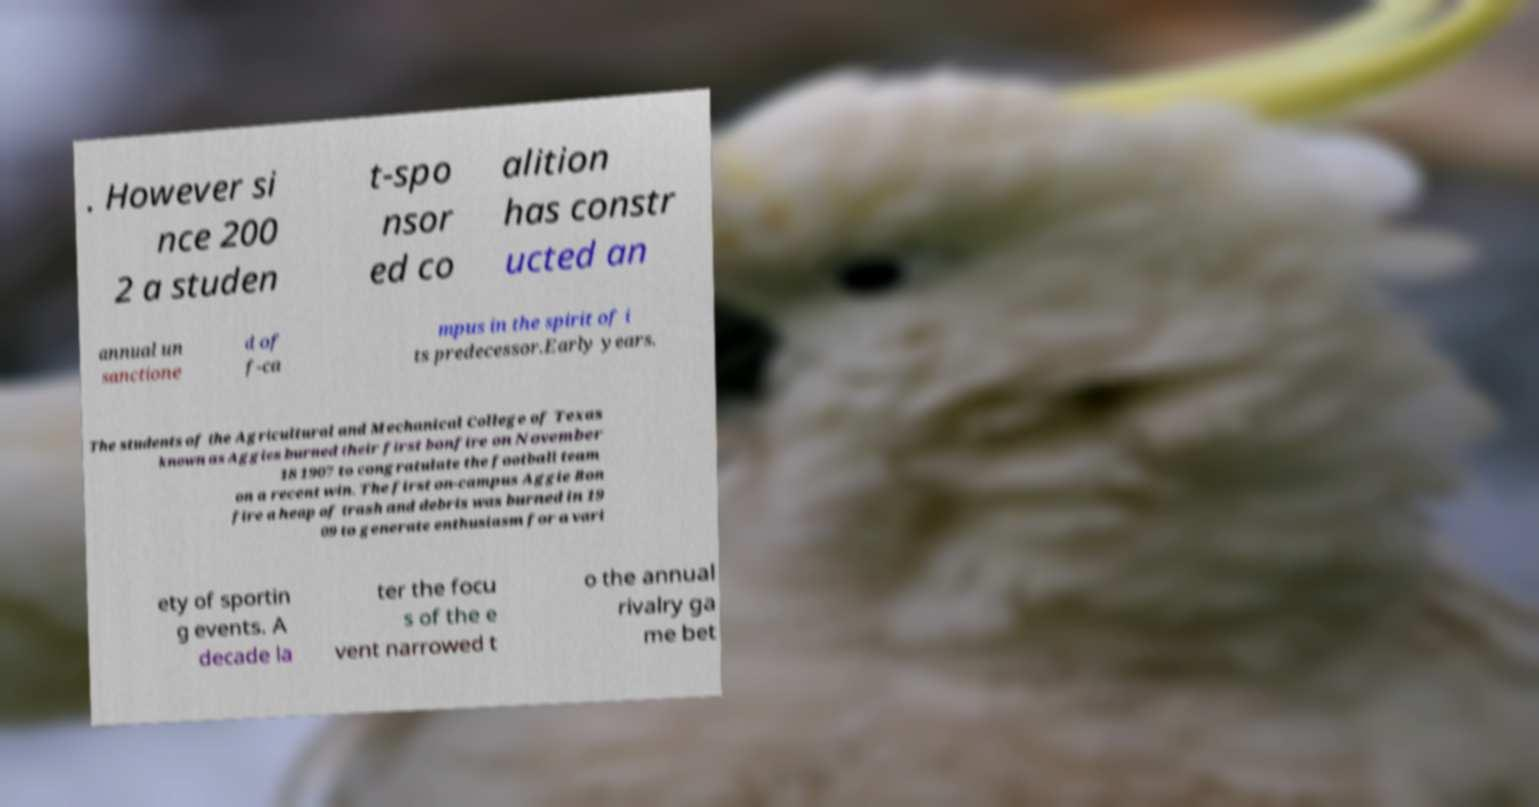Please identify and transcribe the text found in this image. . However si nce 200 2 a studen t-spo nsor ed co alition has constr ucted an annual un sanctione d of f-ca mpus in the spirit of i ts predecessor.Early years. The students of the Agricultural and Mechanical College of Texas known as Aggies burned their first bonfire on November 18 1907 to congratulate the football team on a recent win. The first on-campus Aggie Bon fire a heap of trash and debris was burned in 19 09 to generate enthusiasm for a vari ety of sportin g events. A decade la ter the focu s of the e vent narrowed t o the annual rivalry ga me bet 